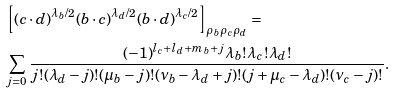Convert formula to latex. <formula><loc_0><loc_0><loc_500><loc_500>& \left [ ( { c \cdot d } ) ^ { \lambda _ { b } / 2 } ( { b \cdot c } ) ^ { \lambda _ { d } / 2 } ( { b \cdot d } ) ^ { \lambda _ { c } / 2 } \right ] _ { \rho _ { b } \rho _ { c } \rho _ { d } } = \\ & \sum _ { j = 0 } \frac { ( - 1 ) ^ { l _ { c } + l _ { d } + m _ { b } + j } \lambda _ { b } ! \lambda _ { c } ! \lambda _ { d } ! } { j ! ( \lambda _ { d } - j ) ! ( \mu _ { b } - j ) ! ( \nu _ { b } - \lambda _ { d } + j ) ! ( j + \mu _ { c } - \lambda _ { d } ) ! ( \nu _ { c } - j ) ! } .</formula> 